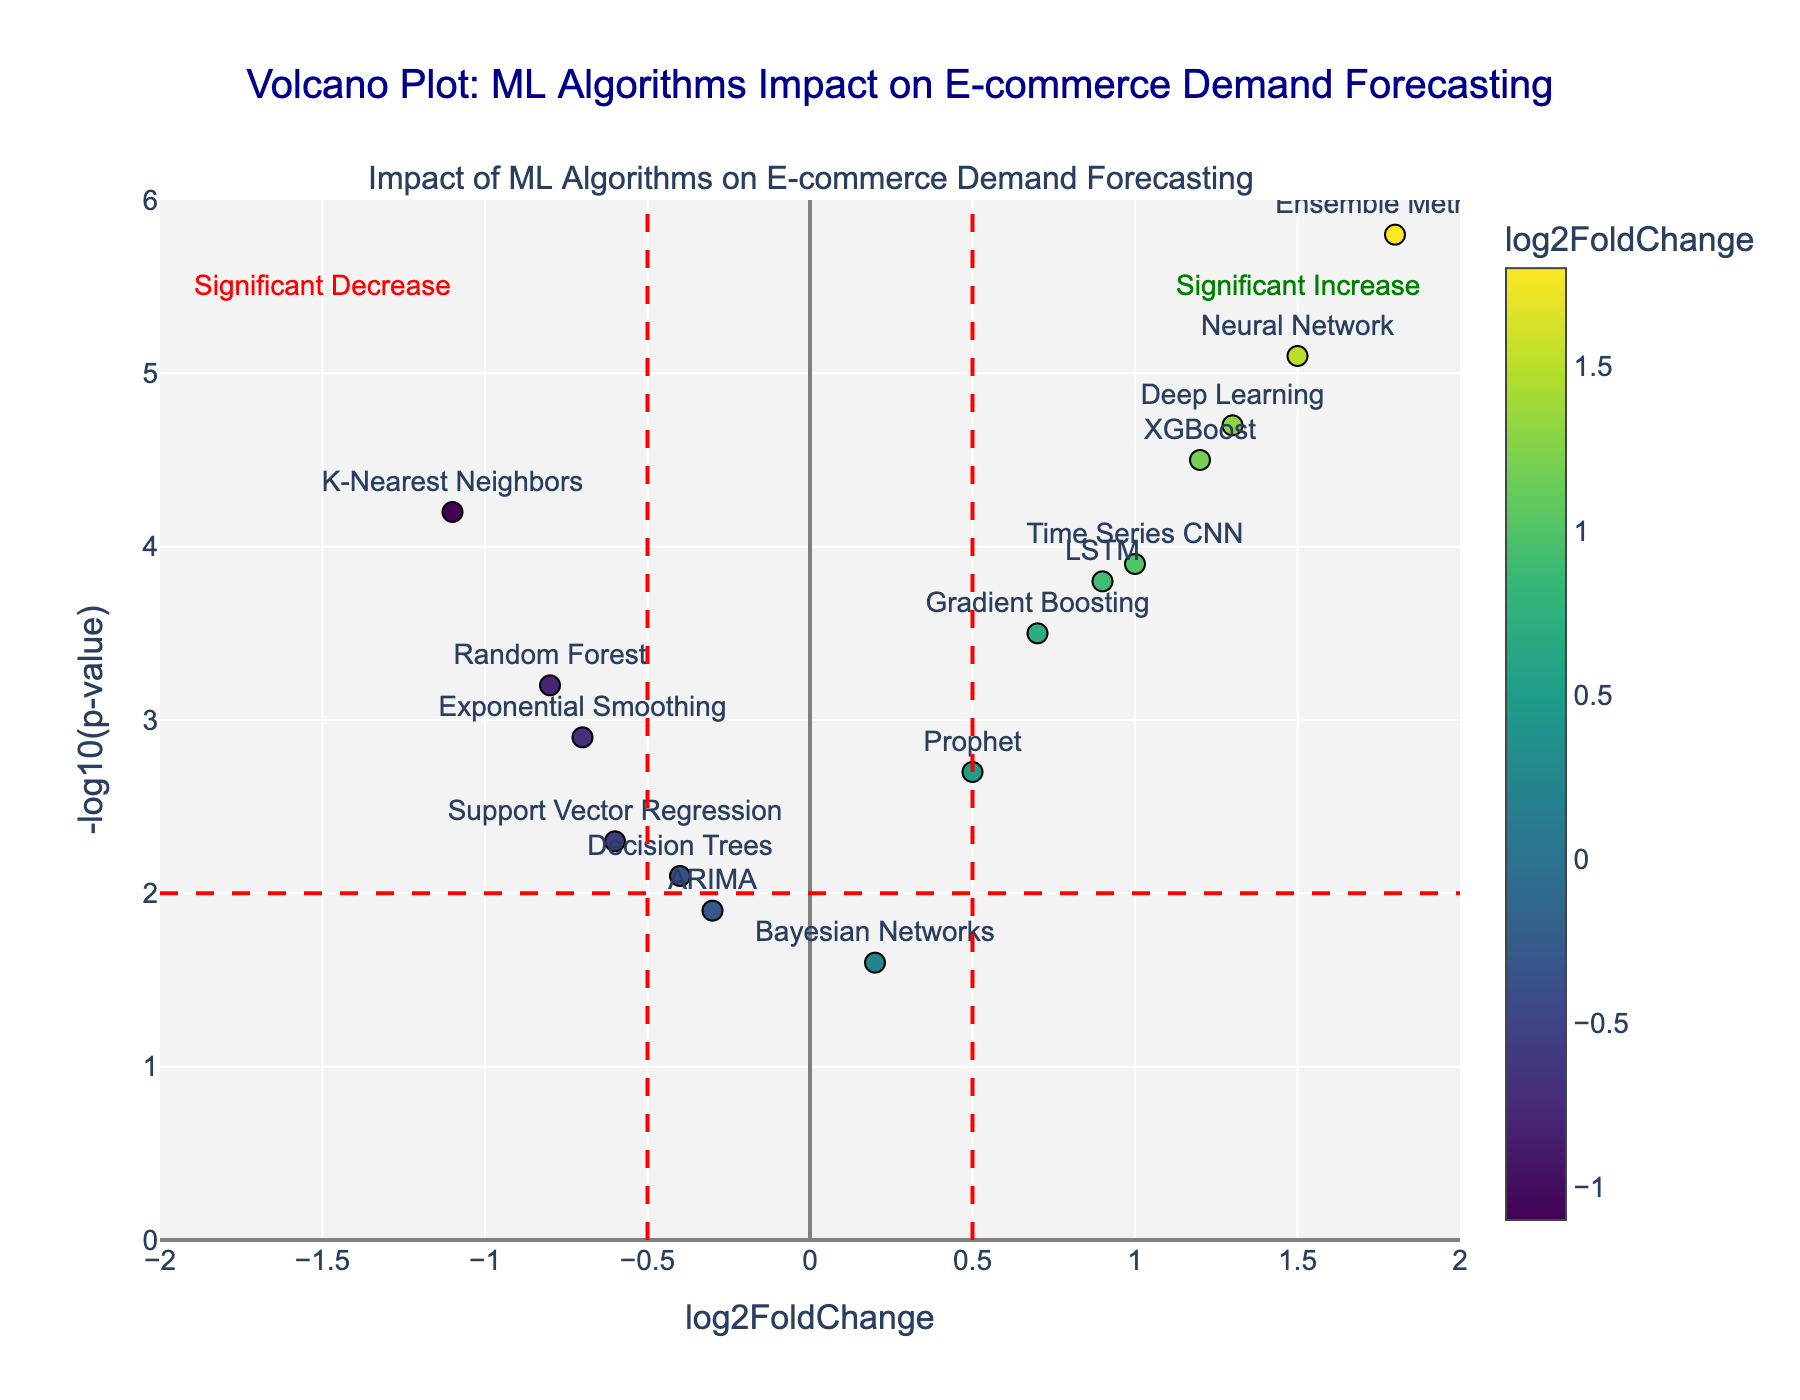What is the title of the plot? The title is displayed at the top of the plot and reads, "Volcano Plot: ML Algorithms Impact on E-commerce Demand Forecasting".
Answer: Volcano Plot: ML Algorithms Impact on E-commerce Demand Forecasting How many algorithms show a significant increase in demand forecasting accuracy? A significant increase is indicated by points with a log2FoldChange greater than 0.5 and a -log10(p-value) greater than 2. By counting these points, we find the following have significant increases: XGBoost, Neural Network, Ensemble Methods, Deep Learning, Time Series CNN, Gradient Boosting, and LSTM.
Answer: 7 Which algorithm has the highest log2FoldChange value? Among the plotted points, the algorithm with the highest log2FoldChange is "Ensemble Methods" with a value of 1.8.
Answer: Ensemble Methods What is the negLogPvalue for the Random Forest algorithm? The Random Forest algorithm is represented by a point located on the plot. The corresponding y-value for this point is 3.2, indicating its -log10(p-value).
Answer: 3.2 Which algorithms are close to the threshold for significant increase, and what are their log2FoldChange values? The red vertical lines at ±0.5 are the thresholds. XGBoost, LSTM, and Gradient Boosting are near the right threshold. Their log2FoldChange values are 1.2, 0.9, and 0.7, respectively.
Answer: XGBoost (1.2), LSTM (0.9), Gradient Boosting (0.7) Compare the -log10(p-value) of Decision Trees and Exponential Smoothing. Which one is higher? Locate the points for Decision Trees and Exponential Smoothing on the plot. Decision Trees have a -log10(p-value) of 2.1, while Exponential Smoothing is at 2.9. Thus, Exponential Smoothing has a higher value.
Answer: Exponential Smoothing Which algorithms show a significant decrease in demand forecasting accuracy and what is their log2FoldChange? Significant decreases are indicated by a log2FoldChange less than -0.5 and a -log10(p-value) greater than 2. The algorithms are Random Forest (-0.8), Support Vector Regression (-0.6), and K-Nearest Neighbors (-1.1).
Answer: Random Forest (-0.8), Support Vector Regression (-0.6), K-Nearest Neighbors (-1.1) What does the position of the ARIMA algorithm tell you about its impact on demand forecasting accuracy? The point for ARIMA is located at a log2FoldChange of -0.3 and a -log10(p-value) of 1.9. Being close to the origin and below the significance threshold lines indicates it has a negligible impact on demand forecasting accuracy.
Answer: Negligible impact Which algorithms lie above the -log10(p-value) threshold line but show a minimal fold change? The threshold for significant p-value is -log10(p-value) = 2. Algorithms above this line with log2FoldChange close to 0 are ARIMA (-0.3), Decision Trees (-0.4), and Bayesian Networks (0.2).
Answer: ARIMA, Decision Trees, Bayesian Networks 